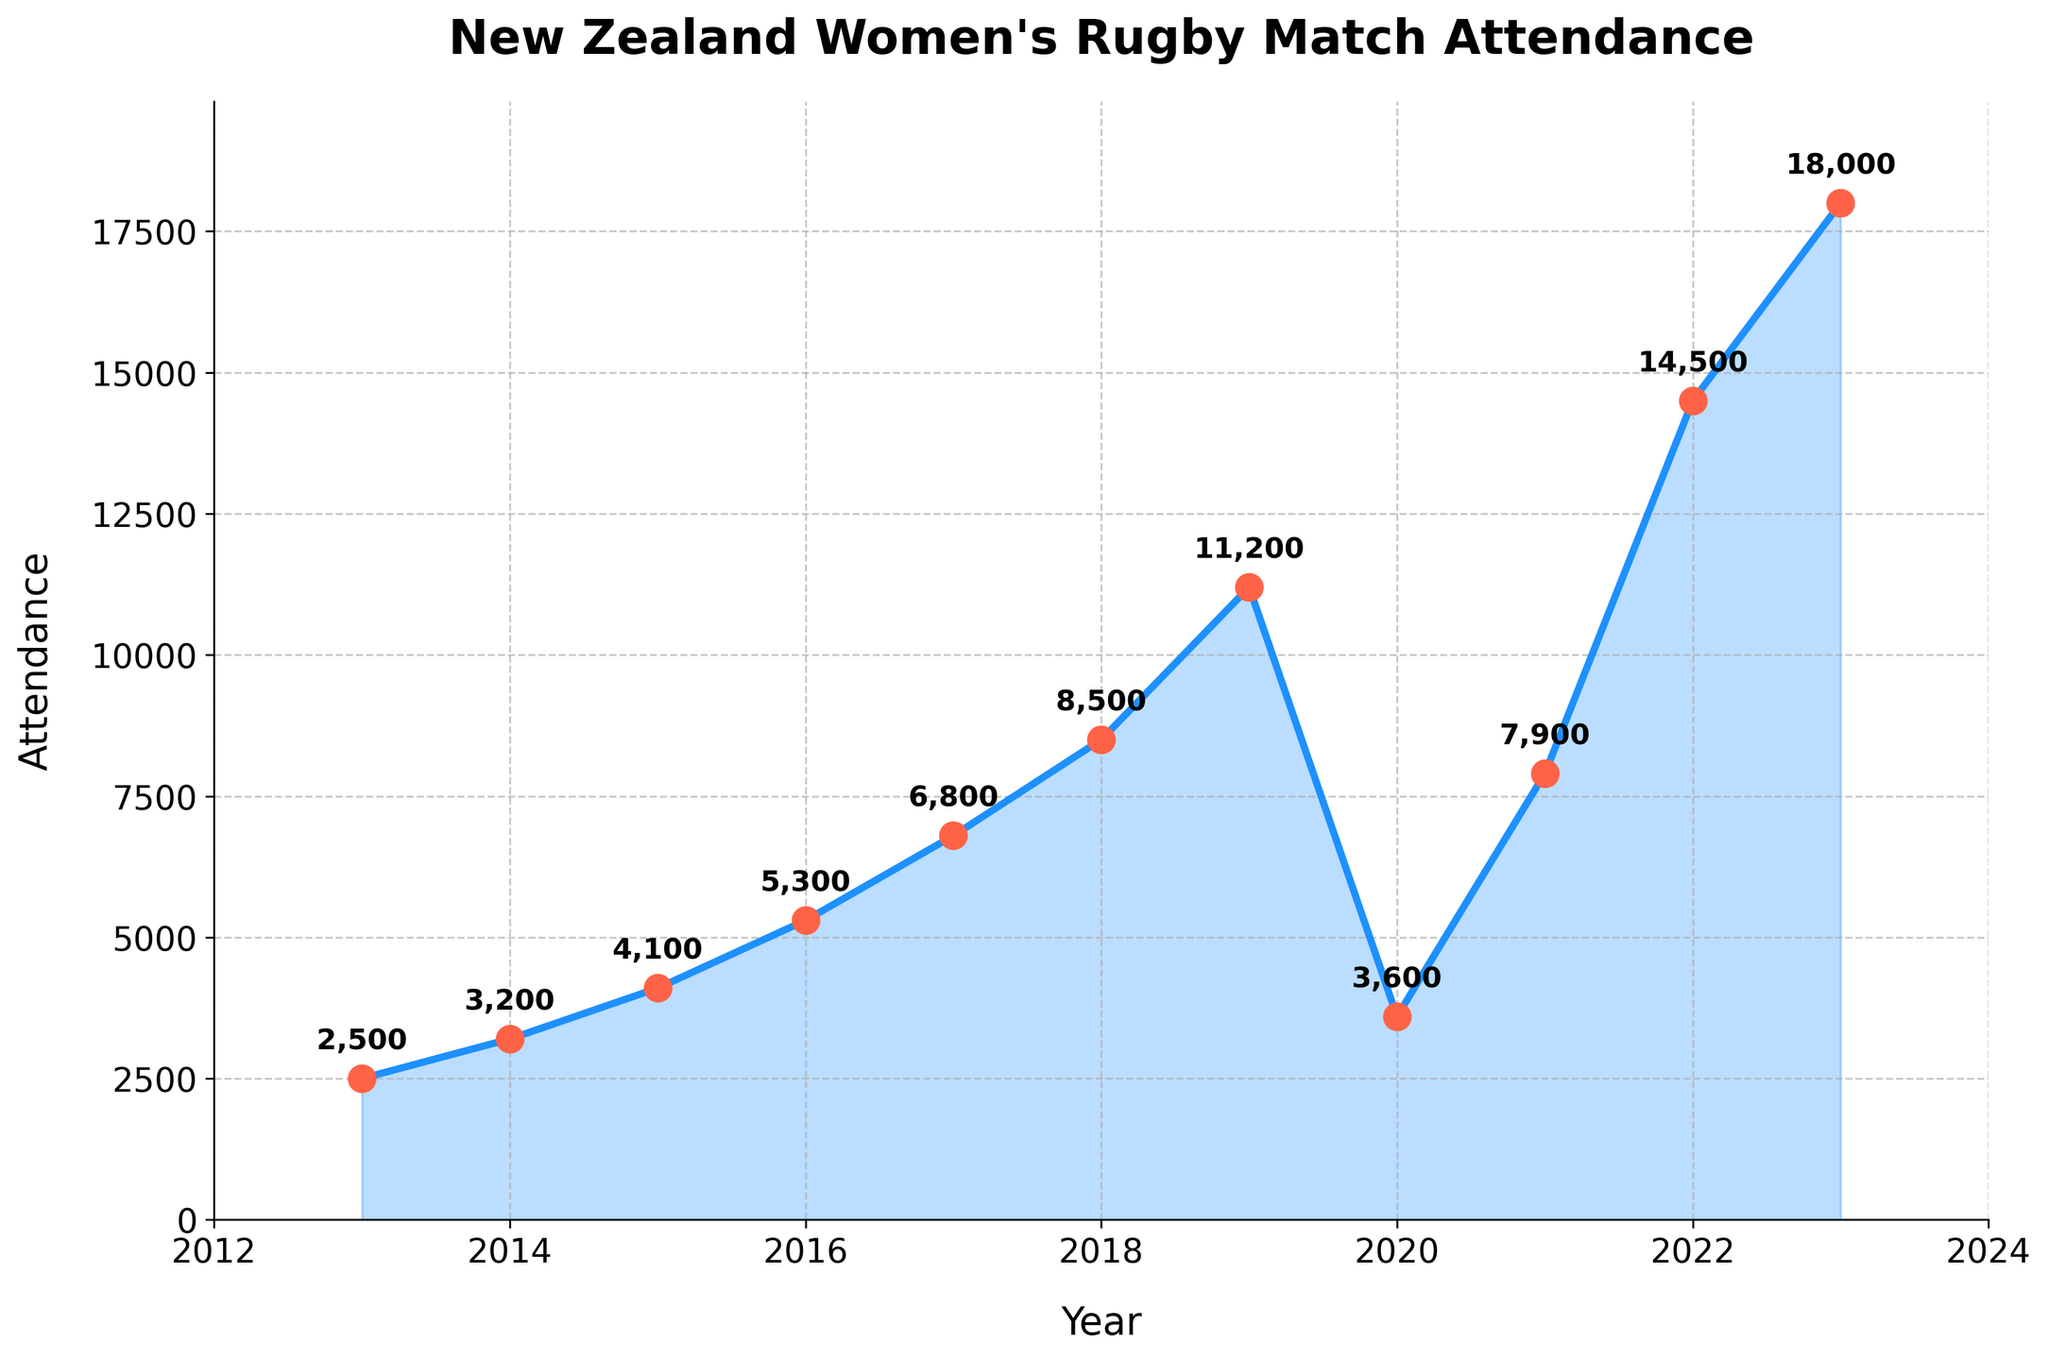What was the attendance in 2023? The attendance data point for the year 2023 is represented at the far right of the line chart. The value at this point is 18,000.
Answer: 18,000 Which year had the lowest attendance? By observing the lowest point on the line chart, the attendance in 2013 had the lowest value of 2,500.
Answer: 2013 How does the attendance in 2022 compare to 2020? The attendance in 2022 is 14,500 while in 2020 it is 3,600. So, the attendance in 2022 is much higher than in 2020.
Answer: 2022 is higher What is the average attendance from 2013 to 2023? To calculate the average attendance, sum all the attendance values from each year and divide by the number of years. (2500 + 3200 + 4100 + 5300 + 6800 + 8500 + 11200 + 3600 + 7900 + 14500 + 18000) / 11 = 7,455.
Answer: 7,455 In which years did attendance decline compared to the previous year? Lower points on the plot compared to the previous point indicate a decline. Attendance decreased from 2019 to 2020.
Answer: 2020 What was the total attendance from 2017 through 2019? Summing the attendance for the years 2017, 2018, and 2019: 6,800 + 8,500 + 11,200 = 26,500.
Answer: 26,500 What significant changes in trend do you observe in the plot? The chart shows overall increasing attendance, with a notable dip in 2020, possibly due to external factors like the pandemic. After 2020, attendance sharply increased each year.
Answer: Increase overall, dip in 2020, sharp rise post-2020 How does the attendance in 2021 compare with the attendance in 2018? The attendance in 2018 was 8,500, while in 2021 it was 7,900. The attendance in 2021 is lower than in 2018.
Answer: 2018 is higher Which year showed the highest increase in attendance from the previous year? The largest difference between data points is from 2021 to 2022, where attendance increased from 7,900 to 14,500.
Answer: 2022 How does the attendance trajectory from 2017 to 2019 compare to 2021 to 2023? Both periods show an increasing trend, but the increase from 2021 to 2023 is steeper (from 7,900 to 18,000) compared to 2017 to 2019 (from 6,800 to 11,200).
Answer: 2021-2023 is steeper 